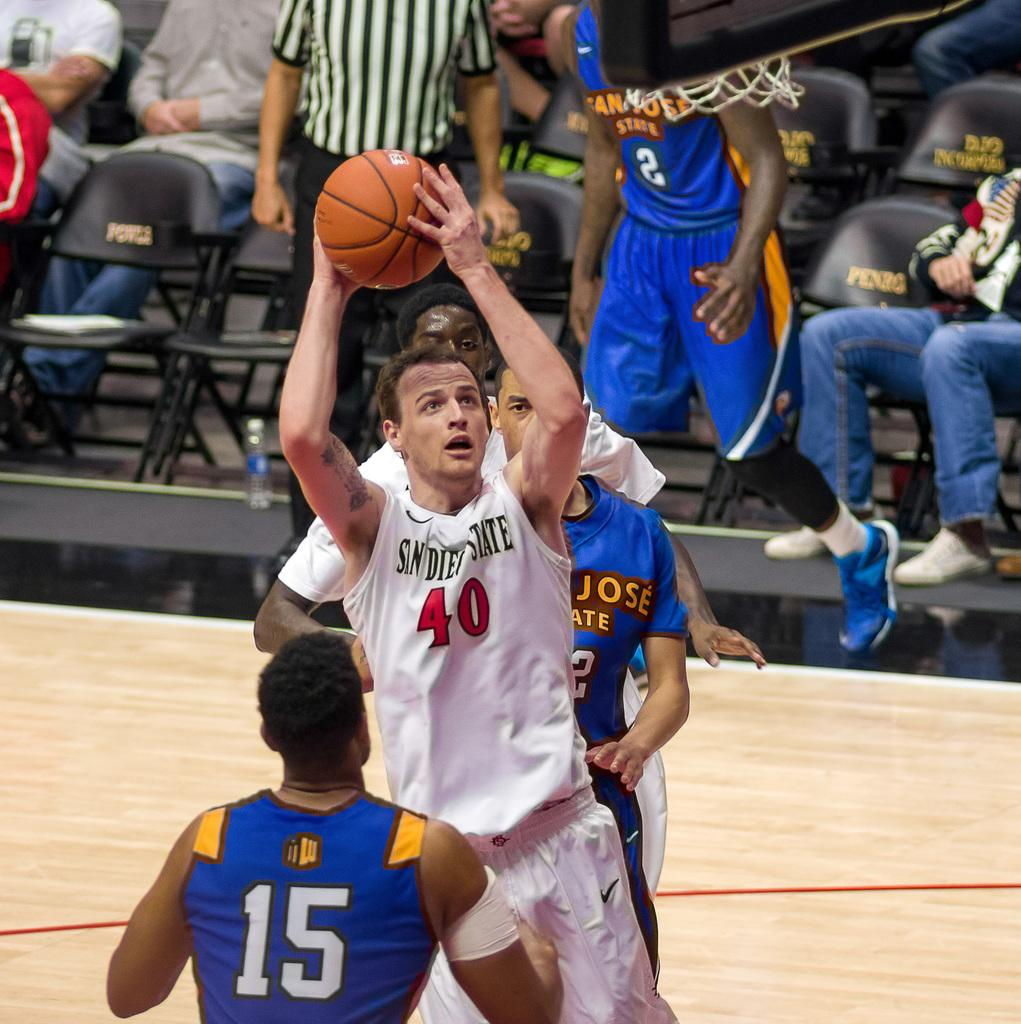How many people are in the image? There are people in the image, but the exact number is not specified. What is one person doing in the image? One person is holding a ball. Can you describe the background of the image? In the background, there is a group of people, the ground, chairs, a bottle, and other objects. What might the people in the background be doing? The people in the background might be engaged in various activities, but the image does not provide specific details. What is the purpose of the chairs in the background? The chairs in the background might be for sitting or decoration, but the image does not provide specific details. How many books are stacked on the elbow of the person holding the ball? There are no books visible in the image, and no one's elbow is mentioned. 